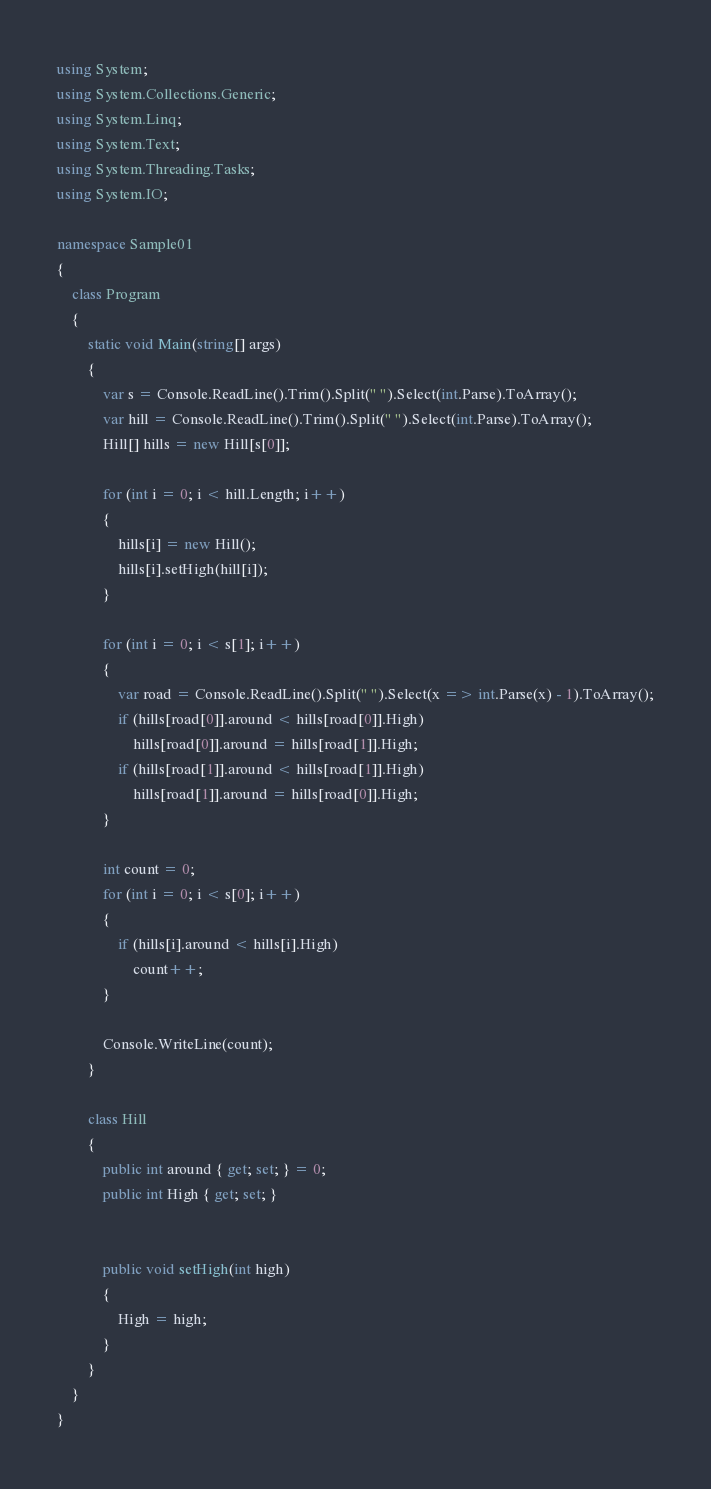Convert code to text. <code><loc_0><loc_0><loc_500><loc_500><_C#_>using System;
using System.Collections.Generic;
using System.Linq;
using System.Text;
using System.Threading.Tasks;
using System.IO;

namespace Sample01
{
    class Program
    {
        static void Main(string[] args)
        {
            var s = Console.ReadLine().Trim().Split(" ").Select(int.Parse).ToArray();
            var hill = Console.ReadLine().Trim().Split(" ").Select(int.Parse).ToArray();
            Hill[] hills = new Hill[s[0]];

            for (int i = 0; i < hill.Length; i++)
            {
                hills[i] = new Hill();
                hills[i].setHigh(hill[i]);
            }

            for (int i = 0; i < s[1]; i++)
            {
                var road = Console.ReadLine().Split(" ").Select(x => int.Parse(x) - 1).ToArray();
                if (hills[road[0]].around < hills[road[0]].High)
                    hills[road[0]].around = hills[road[1]].High;
                if (hills[road[1]].around < hills[road[1]].High)
                    hills[road[1]].around = hills[road[0]].High;
            }

            int count = 0;
            for (int i = 0; i < s[0]; i++)
            {
                if (hills[i].around < hills[i].High)
                    count++;
            }

            Console.WriteLine(count);
        }

        class Hill
        {
            public int around { get; set; } = 0;
            public int High { get; set; }


            public void setHigh(int high)
            {
                High = high;
            }
        }
    }
}</code> 